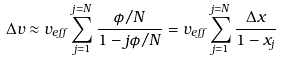Convert formula to latex. <formula><loc_0><loc_0><loc_500><loc_500>\Delta v \approx v _ { e f f } \sum _ { j = 1 } ^ { j = N } { \frac { \phi / N } { 1 - j \phi / N } } = v _ { e f f } \sum _ { j = 1 } ^ { j = N } { \frac { \Delta x } { 1 - x _ { j } } }</formula> 